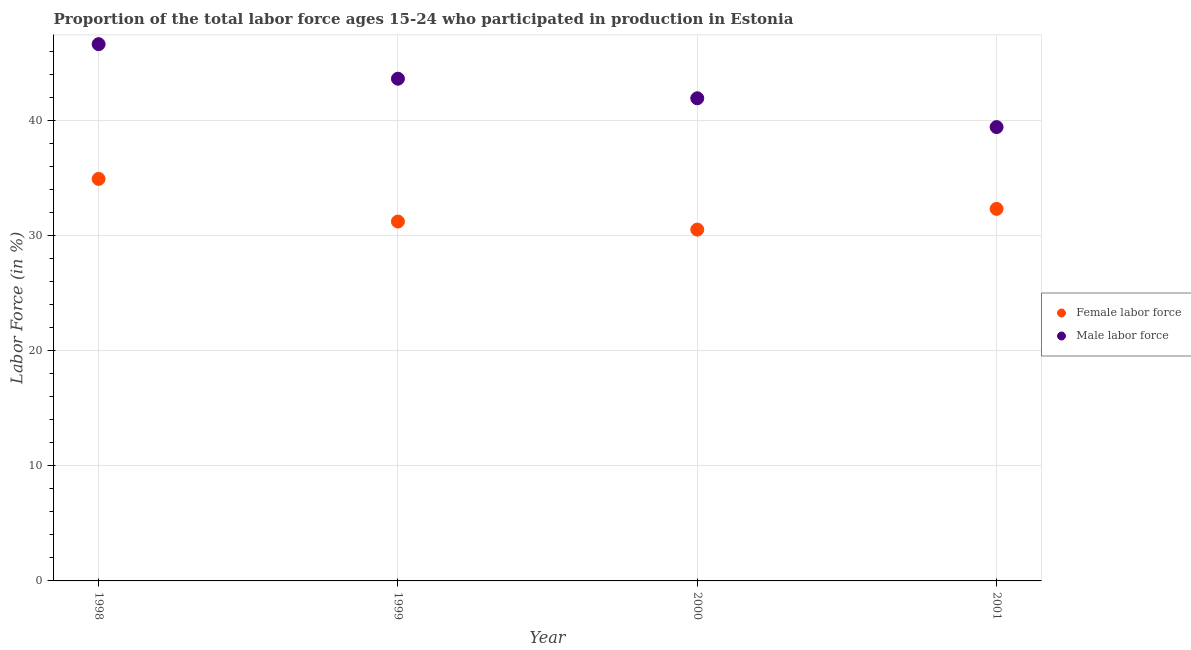How many different coloured dotlines are there?
Your answer should be compact. 2. What is the percentage of female labor force in 2000?
Make the answer very short. 30.5. Across all years, what is the maximum percentage of male labour force?
Keep it short and to the point. 46.6. Across all years, what is the minimum percentage of male labour force?
Keep it short and to the point. 39.4. In which year was the percentage of female labor force maximum?
Make the answer very short. 1998. In which year was the percentage of female labor force minimum?
Your response must be concise. 2000. What is the total percentage of male labour force in the graph?
Offer a terse response. 171.5. What is the difference between the percentage of male labour force in 2000 and that in 2001?
Give a very brief answer. 2.5. What is the difference between the percentage of male labour force in 1998 and the percentage of female labor force in 2000?
Ensure brevity in your answer.  16.1. What is the average percentage of male labour force per year?
Make the answer very short. 42.88. In the year 2001, what is the difference between the percentage of male labour force and percentage of female labor force?
Your answer should be compact. 7.1. In how many years, is the percentage of female labor force greater than 26 %?
Your answer should be very brief. 4. What is the ratio of the percentage of male labour force in 1999 to that in 2000?
Your response must be concise. 1.04. What is the difference between the highest and the second highest percentage of female labor force?
Give a very brief answer. 2.6. What is the difference between the highest and the lowest percentage of female labor force?
Provide a succinct answer. 4.4. Is the sum of the percentage of female labor force in 1999 and 2000 greater than the maximum percentage of male labour force across all years?
Give a very brief answer. Yes. Does the percentage of female labor force monotonically increase over the years?
Give a very brief answer. No. Is the percentage of male labour force strictly less than the percentage of female labor force over the years?
Keep it short and to the point. No. How many dotlines are there?
Your answer should be compact. 2. What is the difference between two consecutive major ticks on the Y-axis?
Offer a terse response. 10. Are the values on the major ticks of Y-axis written in scientific E-notation?
Your response must be concise. No. Does the graph contain any zero values?
Provide a short and direct response. No. Does the graph contain grids?
Keep it short and to the point. Yes. Where does the legend appear in the graph?
Keep it short and to the point. Center right. How many legend labels are there?
Offer a very short reply. 2. How are the legend labels stacked?
Your answer should be very brief. Vertical. What is the title of the graph?
Your answer should be compact. Proportion of the total labor force ages 15-24 who participated in production in Estonia. What is the label or title of the X-axis?
Offer a very short reply. Year. What is the Labor Force (in %) in Female labor force in 1998?
Provide a short and direct response. 34.9. What is the Labor Force (in %) in Male labor force in 1998?
Make the answer very short. 46.6. What is the Labor Force (in %) in Female labor force in 1999?
Keep it short and to the point. 31.2. What is the Labor Force (in %) of Male labor force in 1999?
Give a very brief answer. 43.6. What is the Labor Force (in %) in Female labor force in 2000?
Ensure brevity in your answer.  30.5. What is the Labor Force (in %) in Male labor force in 2000?
Your answer should be compact. 41.9. What is the Labor Force (in %) of Female labor force in 2001?
Make the answer very short. 32.3. What is the Labor Force (in %) in Male labor force in 2001?
Give a very brief answer. 39.4. Across all years, what is the maximum Labor Force (in %) of Female labor force?
Keep it short and to the point. 34.9. Across all years, what is the maximum Labor Force (in %) in Male labor force?
Your answer should be very brief. 46.6. Across all years, what is the minimum Labor Force (in %) in Female labor force?
Give a very brief answer. 30.5. Across all years, what is the minimum Labor Force (in %) in Male labor force?
Provide a short and direct response. 39.4. What is the total Labor Force (in %) in Female labor force in the graph?
Give a very brief answer. 128.9. What is the total Labor Force (in %) of Male labor force in the graph?
Your answer should be compact. 171.5. What is the difference between the Labor Force (in %) of Male labor force in 1998 and that in 1999?
Give a very brief answer. 3. What is the difference between the Labor Force (in %) of Female labor force in 1998 and that in 2001?
Keep it short and to the point. 2.6. What is the difference between the Labor Force (in %) of Male labor force in 1998 and that in 2001?
Your answer should be very brief. 7.2. What is the difference between the Labor Force (in %) in Male labor force in 1999 and that in 2001?
Make the answer very short. 4.2. What is the difference between the Labor Force (in %) in Female labor force in 2000 and that in 2001?
Offer a terse response. -1.8. What is the difference between the Labor Force (in %) of Female labor force in 1998 and the Labor Force (in %) of Male labor force in 1999?
Offer a very short reply. -8.7. What is the difference between the Labor Force (in %) of Female labor force in 1998 and the Labor Force (in %) of Male labor force in 2000?
Ensure brevity in your answer.  -7. What is the difference between the Labor Force (in %) of Female labor force in 1998 and the Labor Force (in %) of Male labor force in 2001?
Offer a very short reply. -4.5. What is the difference between the Labor Force (in %) of Female labor force in 1999 and the Labor Force (in %) of Male labor force in 2000?
Your answer should be very brief. -10.7. What is the difference between the Labor Force (in %) in Female labor force in 2000 and the Labor Force (in %) in Male labor force in 2001?
Your answer should be very brief. -8.9. What is the average Labor Force (in %) in Female labor force per year?
Provide a succinct answer. 32.23. What is the average Labor Force (in %) in Male labor force per year?
Keep it short and to the point. 42.88. In the year 1998, what is the difference between the Labor Force (in %) in Female labor force and Labor Force (in %) in Male labor force?
Provide a succinct answer. -11.7. In the year 2000, what is the difference between the Labor Force (in %) in Female labor force and Labor Force (in %) in Male labor force?
Your response must be concise. -11.4. What is the ratio of the Labor Force (in %) of Female labor force in 1998 to that in 1999?
Your answer should be very brief. 1.12. What is the ratio of the Labor Force (in %) in Male labor force in 1998 to that in 1999?
Your response must be concise. 1.07. What is the ratio of the Labor Force (in %) of Female labor force in 1998 to that in 2000?
Make the answer very short. 1.14. What is the ratio of the Labor Force (in %) of Male labor force in 1998 to that in 2000?
Offer a very short reply. 1.11. What is the ratio of the Labor Force (in %) of Female labor force in 1998 to that in 2001?
Your response must be concise. 1.08. What is the ratio of the Labor Force (in %) in Male labor force in 1998 to that in 2001?
Ensure brevity in your answer.  1.18. What is the ratio of the Labor Force (in %) of Male labor force in 1999 to that in 2000?
Make the answer very short. 1.04. What is the ratio of the Labor Force (in %) of Female labor force in 1999 to that in 2001?
Your response must be concise. 0.97. What is the ratio of the Labor Force (in %) in Male labor force in 1999 to that in 2001?
Ensure brevity in your answer.  1.11. What is the ratio of the Labor Force (in %) of Female labor force in 2000 to that in 2001?
Give a very brief answer. 0.94. What is the ratio of the Labor Force (in %) in Male labor force in 2000 to that in 2001?
Your response must be concise. 1.06. What is the difference between the highest and the lowest Labor Force (in %) of Male labor force?
Your answer should be compact. 7.2. 